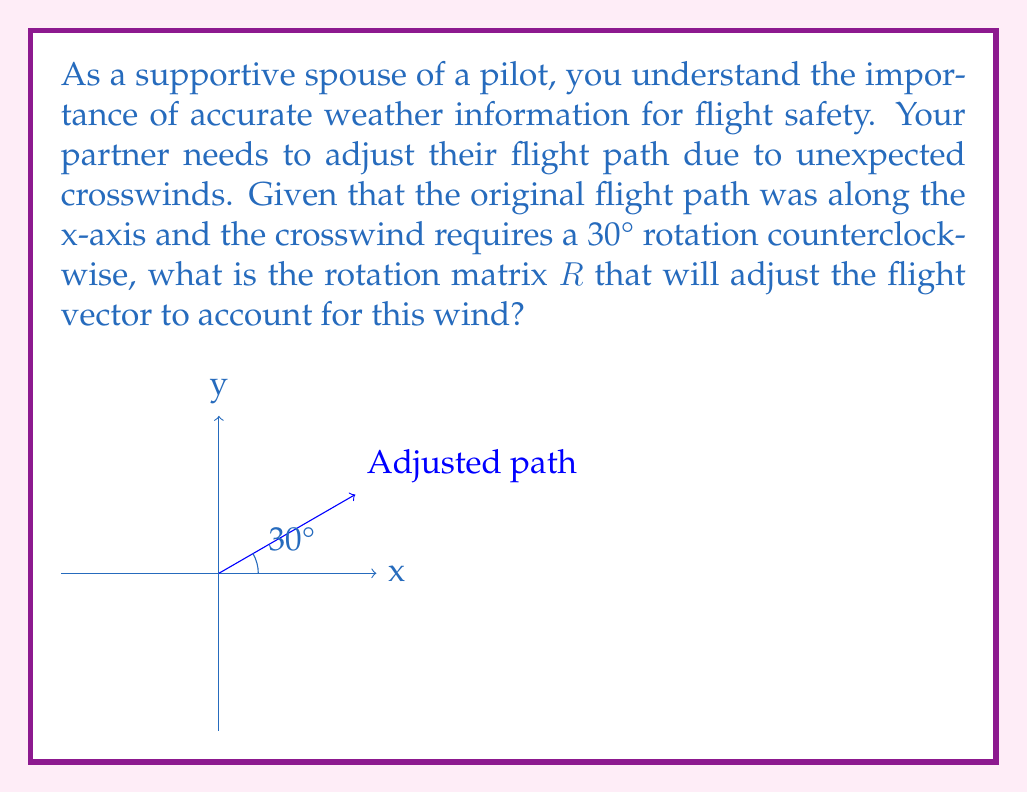Teach me how to tackle this problem. To solve this problem, we'll follow these steps:

1) The general form of a 2D rotation matrix for a counterclockwise rotation by an angle $\theta$ is:

   $$R = \begin{bmatrix} 
   \cos\theta & -\sin\theta \\
   \sin\theta & \cos\theta 
   \end{bmatrix}$$

2) In this case, $\theta = 30°$. We need to calculate $\cos(30°)$ and $\sin(30°)$.

3) $\cos(30°) = \frac{\sqrt{3}}{2} \approx 0.866$

4) $\sin(30°) = \frac{1}{2} = 0.5$

5) Substituting these values into the rotation matrix:

   $$R = \begin{bmatrix} 
   \frac{\sqrt{3}}{2} & -\frac{1}{2} \\
   \frac{1}{2} & \frac{\sqrt{3}}{2} 
   \end{bmatrix}$$

This matrix $R$, when multiplied with any vector representing the original flight path, will rotate it by 30° counterclockwise, adjusting for the crosswind.
Answer: $$R = \begin{bmatrix} 
\frac{\sqrt{3}}{2} & -\frac{1}{2} \\
\frac{1}{2} & \frac{\sqrt{3}}{2} 
\end{bmatrix}$$ 